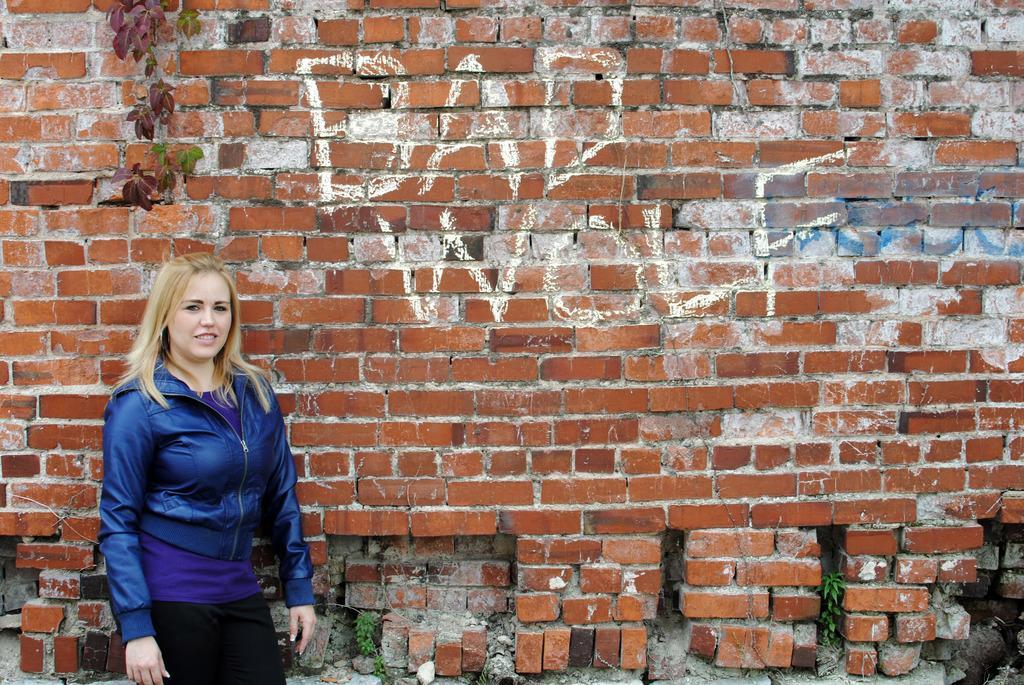Describe this image in one or two sentences. In this picture I can see a woman standing, and in the background there are plants and there is something written on the wall. 